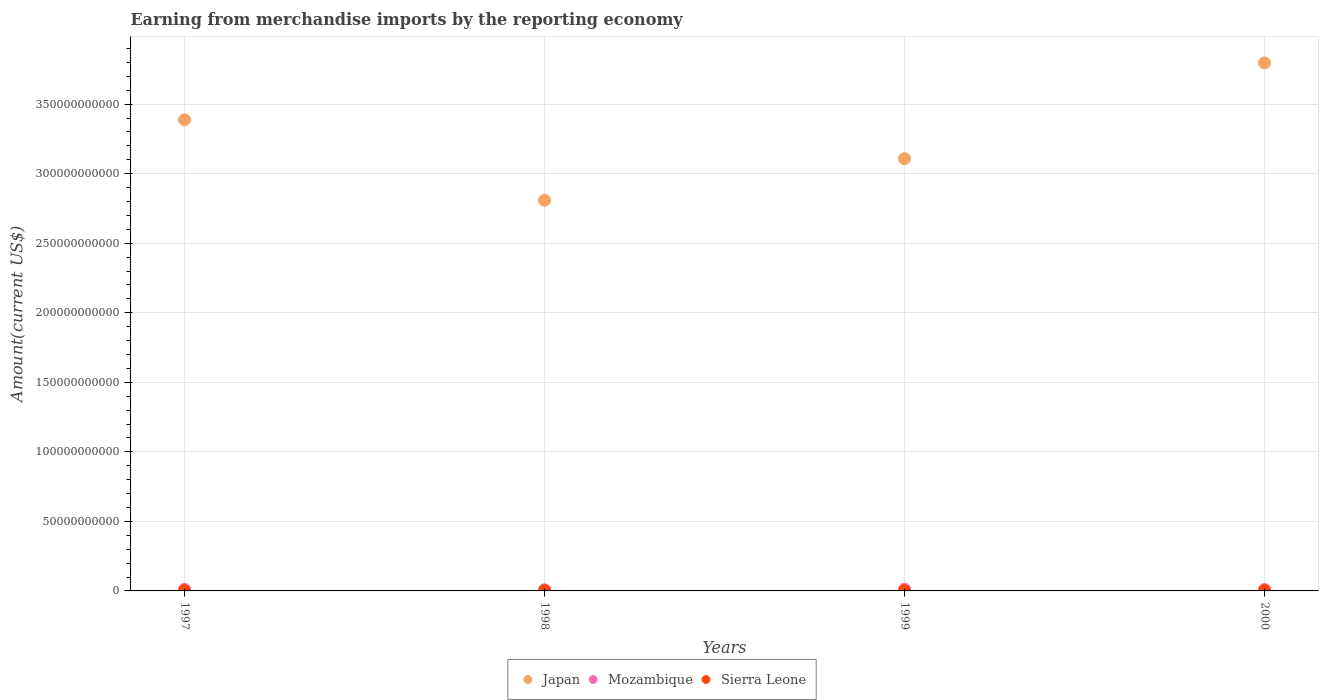Is the number of dotlines equal to the number of legend labels?
Make the answer very short. Yes. What is the amount earned from merchandise imports in Mozambique in 1997?
Ensure brevity in your answer.  1.10e+09. Across all years, what is the maximum amount earned from merchandise imports in Mozambique?
Your answer should be compact. 1.20e+09. Across all years, what is the minimum amount earned from merchandise imports in Mozambique?
Provide a succinct answer. 8.17e+08. In which year was the amount earned from merchandise imports in Mozambique maximum?
Provide a succinct answer. 1999. What is the total amount earned from merchandise imports in Sierra Leone in the graph?
Your answer should be compact. 9.47e+08. What is the difference between the amount earned from merchandise imports in Mozambique in 1998 and that in 1999?
Your answer should be very brief. -3.82e+08. What is the difference between the amount earned from merchandise imports in Japan in 1998 and the amount earned from merchandise imports in Mozambique in 1999?
Keep it short and to the point. 2.80e+11. What is the average amount earned from merchandise imports in Japan per year?
Ensure brevity in your answer.  3.27e+11. In the year 1999, what is the difference between the amount earned from merchandise imports in Mozambique and amount earned from merchandise imports in Sierra Leone?
Offer a very short reply. 1.00e+09. In how many years, is the amount earned from merchandise imports in Mozambique greater than 370000000000 US$?
Offer a terse response. 0. What is the ratio of the amount earned from merchandise imports in Sierra Leone in 1997 to that in 1998?
Offer a terse response. 1.19. What is the difference between the highest and the second highest amount earned from merchandise imports in Sierra Leone?
Provide a succinct answer. 8.17e+07. What is the difference between the highest and the lowest amount earned from merchandise imports in Sierra Leone?
Your answer should be very brief. 1.20e+08. In how many years, is the amount earned from merchandise imports in Japan greater than the average amount earned from merchandise imports in Japan taken over all years?
Give a very brief answer. 2. Is the sum of the amount earned from merchandise imports in Mozambique in 1997 and 1999 greater than the maximum amount earned from merchandise imports in Sierra Leone across all years?
Offer a very short reply. Yes. Does the graph contain any zero values?
Your response must be concise. No. Where does the legend appear in the graph?
Give a very brief answer. Bottom center. How many legend labels are there?
Your answer should be compact. 3. How are the legend labels stacked?
Keep it short and to the point. Horizontal. What is the title of the graph?
Offer a terse response. Earning from merchandise imports by the reporting economy. What is the label or title of the X-axis?
Provide a succinct answer. Years. What is the label or title of the Y-axis?
Your answer should be compact. Amount(current US$). What is the Amount(current US$) of Japan in 1997?
Keep it short and to the point. 3.39e+11. What is the Amount(current US$) of Mozambique in 1997?
Provide a short and direct response. 1.10e+09. What is the Amount(current US$) of Sierra Leone in 1997?
Your answer should be compact. 2.35e+08. What is the Amount(current US$) in Japan in 1998?
Your answer should be compact. 2.81e+11. What is the Amount(current US$) of Mozambique in 1998?
Your answer should be compact. 8.17e+08. What is the Amount(current US$) of Sierra Leone in 1998?
Offer a terse response. 1.97e+08. What is the Amount(current US$) in Japan in 1999?
Your answer should be very brief. 3.11e+11. What is the Amount(current US$) of Mozambique in 1999?
Your response must be concise. 1.20e+09. What is the Amount(current US$) of Sierra Leone in 1999?
Keep it short and to the point. 1.99e+08. What is the Amount(current US$) of Japan in 2000?
Keep it short and to the point. 3.80e+11. What is the Amount(current US$) in Mozambique in 2000?
Make the answer very short. 1.05e+09. What is the Amount(current US$) in Sierra Leone in 2000?
Provide a short and direct response. 3.16e+08. Across all years, what is the maximum Amount(current US$) in Japan?
Ensure brevity in your answer.  3.80e+11. Across all years, what is the maximum Amount(current US$) in Mozambique?
Ensure brevity in your answer.  1.20e+09. Across all years, what is the maximum Amount(current US$) in Sierra Leone?
Give a very brief answer. 3.16e+08. Across all years, what is the minimum Amount(current US$) in Japan?
Provide a short and direct response. 2.81e+11. Across all years, what is the minimum Amount(current US$) of Mozambique?
Offer a terse response. 8.17e+08. Across all years, what is the minimum Amount(current US$) in Sierra Leone?
Provide a succinct answer. 1.97e+08. What is the total Amount(current US$) in Japan in the graph?
Provide a succinct answer. 1.31e+12. What is the total Amount(current US$) in Mozambique in the graph?
Ensure brevity in your answer.  4.16e+09. What is the total Amount(current US$) of Sierra Leone in the graph?
Ensure brevity in your answer.  9.47e+08. What is the difference between the Amount(current US$) in Japan in 1997 and that in 1998?
Make the answer very short. 5.78e+1. What is the difference between the Amount(current US$) of Mozambique in 1997 and that in 1998?
Provide a short and direct response. 2.79e+08. What is the difference between the Amount(current US$) of Sierra Leone in 1997 and that in 1998?
Ensure brevity in your answer.  3.80e+07. What is the difference between the Amount(current US$) in Japan in 1997 and that in 1999?
Your answer should be compact. 2.79e+1. What is the difference between the Amount(current US$) in Mozambique in 1997 and that in 1999?
Offer a terse response. -1.04e+08. What is the difference between the Amount(current US$) in Sierra Leone in 1997 and that in 1999?
Provide a succinct answer. 3.55e+07. What is the difference between the Amount(current US$) in Japan in 1997 and that in 2000?
Give a very brief answer. -4.09e+1. What is the difference between the Amount(current US$) of Mozambique in 1997 and that in 2000?
Give a very brief answer. 4.99e+07. What is the difference between the Amount(current US$) in Sierra Leone in 1997 and that in 2000?
Ensure brevity in your answer.  -8.17e+07. What is the difference between the Amount(current US$) in Japan in 1998 and that in 1999?
Ensure brevity in your answer.  -2.99e+1. What is the difference between the Amount(current US$) in Mozambique in 1998 and that in 1999?
Provide a short and direct response. -3.82e+08. What is the difference between the Amount(current US$) in Sierra Leone in 1998 and that in 1999?
Your response must be concise. -2.58e+06. What is the difference between the Amount(current US$) of Japan in 1998 and that in 2000?
Your answer should be compact. -9.87e+1. What is the difference between the Amount(current US$) in Mozambique in 1998 and that in 2000?
Offer a terse response. -2.29e+08. What is the difference between the Amount(current US$) of Sierra Leone in 1998 and that in 2000?
Provide a succinct answer. -1.20e+08. What is the difference between the Amount(current US$) in Japan in 1999 and that in 2000?
Give a very brief answer. -6.88e+1. What is the difference between the Amount(current US$) in Mozambique in 1999 and that in 2000?
Provide a short and direct response. 1.54e+08. What is the difference between the Amount(current US$) of Sierra Leone in 1999 and that in 2000?
Make the answer very short. -1.17e+08. What is the difference between the Amount(current US$) in Japan in 1997 and the Amount(current US$) in Mozambique in 1998?
Offer a terse response. 3.38e+11. What is the difference between the Amount(current US$) in Japan in 1997 and the Amount(current US$) in Sierra Leone in 1998?
Your answer should be compact. 3.39e+11. What is the difference between the Amount(current US$) of Mozambique in 1997 and the Amount(current US$) of Sierra Leone in 1998?
Your response must be concise. 9.00e+08. What is the difference between the Amount(current US$) of Japan in 1997 and the Amount(current US$) of Mozambique in 1999?
Provide a short and direct response. 3.38e+11. What is the difference between the Amount(current US$) in Japan in 1997 and the Amount(current US$) in Sierra Leone in 1999?
Keep it short and to the point. 3.39e+11. What is the difference between the Amount(current US$) of Mozambique in 1997 and the Amount(current US$) of Sierra Leone in 1999?
Keep it short and to the point. 8.97e+08. What is the difference between the Amount(current US$) of Japan in 1997 and the Amount(current US$) of Mozambique in 2000?
Your answer should be compact. 3.38e+11. What is the difference between the Amount(current US$) in Japan in 1997 and the Amount(current US$) in Sierra Leone in 2000?
Keep it short and to the point. 3.38e+11. What is the difference between the Amount(current US$) of Mozambique in 1997 and the Amount(current US$) of Sierra Leone in 2000?
Your answer should be compact. 7.80e+08. What is the difference between the Amount(current US$) in Japan in 1998 and the Amount(current US$) in Mozambique in 1999?
Your response must be concise. 2.80e+11. What is the difference between the Amount(current US$) in Japan in 1998 and the Amount(current US$) in Sierra Leone in 1999?
Your response must be concise. 2.81e+11. What is the difference between the Amount(current US$) in Mozambique in 1998 and the Amount(current US$) in Sierra Leone in 1999?
Keep it short and to the point. 6.18e+08. What is the difference between the Amount(current US$) in Japan in 1998 and the Amount(current US$) in Mozambique in 2000?
Provide a short and direct response. 2.80e+11. What is the difference between the Amount(current US$) of Japan in 1998 and the Amount(current US$) of Sierra Leone in 2000?
Your response must be concise. 2.81e+11. What is the difference between the Amount(current US$) of Mozambique in 1998 and the Amount(current US$) of Sierra Leone in 2000?
Give a very brief answer. 5.01e+08. What is the difference between the Amount(current US$) in Japan in 1999 and the Amount(current US$) in Mozambique in 2000?
Offer a very short reply. 3.10e+11. What is the difference between the Amount(current US$) of Japan in 1999 and the Amount(current US$) of Sierra Leone in 2000?
Provide a succinct answer. 3.10e+11. What is the difference between the Amount(current US$) in Mozambique in 1999 and the Amount(current US$) in Sierra Leone in 2000?
Offer a terse response. 8.84e+08. What is the average Amount(current US$) of Japan per year?
Your response must be concise. 3.27e+11. What is the average Amount(current US$) of Mozambique per year?
Your answer should be very brief. 1.04e+09. What is the average Amount(current US$) in Sierra Leone per year?
Your answer should be very brief. 2.37e+08. In the year 1997, what is the difference between the Amount(current US$) of Japan and Amount(current US$) of Mozambique?
Keep it short and to the point. 3.38e+11. In the year 1997, what is the difference between the Amount(current US$) of Japan and Amount(current US$) of Sierra Leone?
Your answer should be very brief. 3.38e+11. In the year 1997, what is the difference between the Amount(current US$) in Mozambique and Amount(current US$) in Sierra Leone?
Your answer should be very brief. 8.62e+08. In the year 1998, what is the difference between the Amount(current US$) of Japan and Amount(current US$) of Mozambique?
Ensure brevity in your answer.  2.80e+11. In the year 1998, what is the difference between the Amount(current US$) in Japan and Amount(current US$) in Sierra Leone?
Keep it short and to the point. 2.81e+11. In the year 1998, what is the difference between the Amount(current US$) in Mozambique and Amount(current US$) in Sierra Leone?
Your response must be concise. 6.21e+08. In the year 1999, what is the difference between the Amount(current US$) in Japan and Amount(current US$) in Mozambique?
Offer a very short reply. 3.10e+11. In the year 1999, what is the difference between the Amount(current US$) in Japan and Amount(current US$) in Sierra Leone?
Your response must be concise. 3.11e+11. In the year 1999, what is the difference between the Amount(current US$) in Mozambique and Amount(current US$) in Sierra Leone?
Keep it short and to the point. 1.00e+09. In the year 2000, what is the difference between the Amount(current US$) in Japan and Amount(current US$) in Mozambique?
Provide a succinct answer. 3.79e+11. In the year 2000, what is the difference between the Amount(current US$) in Japan and Amount(current US$) in Sierra Leone?
Your response must be concise. 3.79e+11. In the year 2000, what is the difference between the Amount(current US$) of Mozambique and Amount(current US$) of Sierra Leone?
Keep it short and to the point. 7.30e+08. What is the ratio of the Amount(current US$) in Japan in 1997 to that in 1998?
Make the answer very short. 1.21. What is the ratio of the Amount(current US$) of Mozambique in 1997 to that in 1998?
Your answer should be compact. 1.34. What is the ratio of the Amount(current US$) of Sierra Leone in 1997 to that in 1998?
Offer a very short reply. 1.19. What is the ratio of the Amount(current US$) of Japan in 1997 to that in 1999?
Your response must be concise. 1.09. What is the ratio of the Amount(current US$) of Mozambique in 1997 to that in 1999?
Your response must be concise. 0.91. What is the ratio of the Amount(current US$) in Sierra Leone in 1997 to that in 1999?
Give a very brief answer. 1.18. What is the ratio of the Amount(current US$) of Japan in 1997 to that in 2000?
Offer a terse response. 0.89. What is the ratio of the Amount(current US$) of Mozambique in 1997 to that in 2000?
Give a very brief answer. 1.05. What is the ratio of the Amount(current US$) of Sierra Leone in 1997 to that in 2000?
Your answer should be compact. 0.74. What is the ratio of the Amount(current US$) of Japan in 1998 to that in 1999?
Offer a very short reply. 0.9. What is the ratio of the Amount(current US$) of Mozambique in 1998 to that in 1999?
Offer a very short reply. 0.68. What is the ratio of the Amount(current US$) in Sierra Leone in 1998 to that in 1999?
Provide a succinct answer. 0.99. What is the ratio of the Amount(current US$) in Japan in 1998 to that in 2000?
Your response must be concise. 0.74. What is the ratio of the Amount(current US$) of Mozambique in 1998 to that in 2000?
Offer a terse response. 0.78. What is the ratio of the Amount(current US$) in Sierra Leone in 1998 to that in 2000?
Your answer should be very brief. 0.62. What is the ratio of the Amount(current US$) in Japan in 1999 to that in 2000?
Your answer should be very brief. 0.82. What is the ratio of the Amount(current US$) in Mozambique in 1999 to that in 2000?
Offer a terse response. 1.15. What is the ratio of the Amount(current US$) in Sierra Leone in 1999 to that in 2000?
Your response must be concise. 0.63. What is the difference between the highest and the second highest Amount(current US$) of Japan?
Make the answer very short. 4.09e+1. What is the difference between the highest and the second highest Amount(current US$) of Mozambique?
Make the answer very short. 1.04e+08. What is the difference between the highest and the second highest Amount(current US$) of Sierra Leone?
Make the answer very short. 8.17e+07. What is the difference between the highest and the lowest Amount(current US$) in Japan?
Ensure brevity in your answer.  9.87e+1. What is the difference between the highest and the lowest Amount(current US$) in Mozambique?
Your answer should be compact. 3.82e+08. What is the difference between the highest and the lowest Amount(current US$) in Sierra Leone?
Your answer should be very brief. 1.20e+08. 